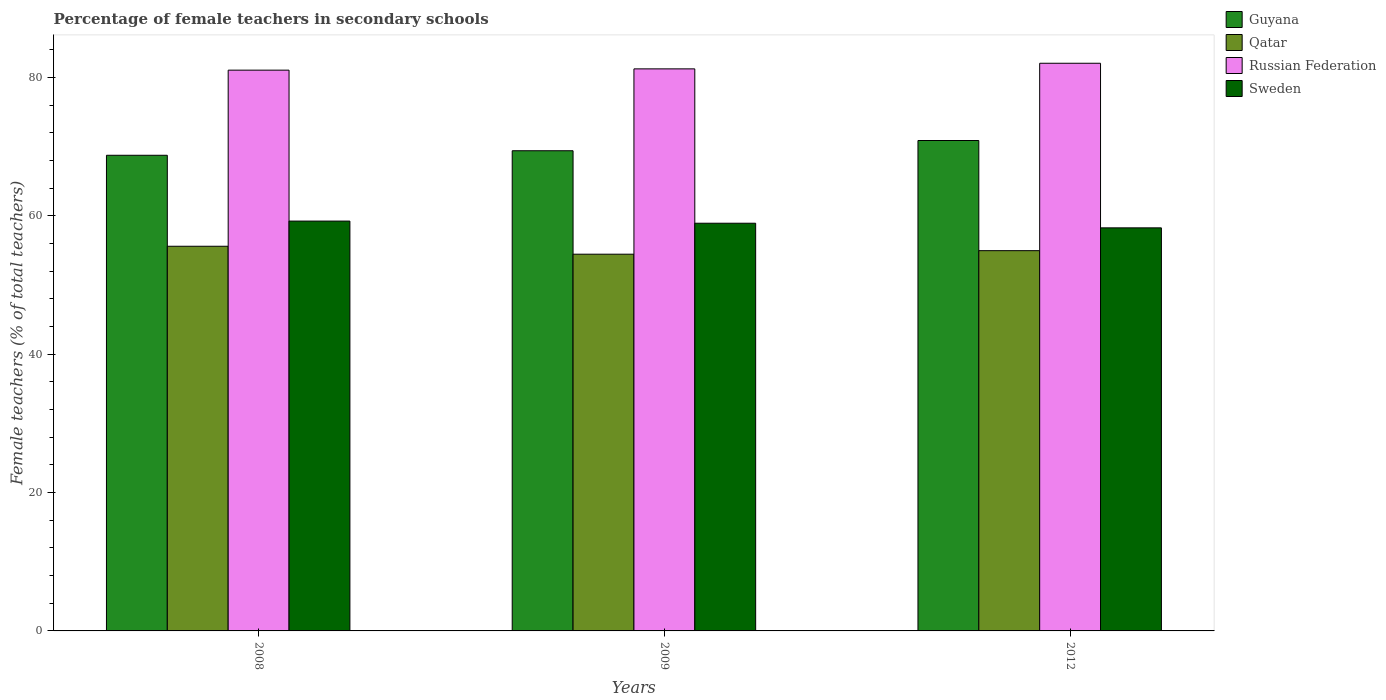How many different coloured bars are there?
Your response must be concise. 4. How many groups of bars are there?
Provide a succinct answer. 3. Are the number of bars on each tick of the X-axis equal?
Keep it short and to the point. Yes. How many bars are there on the 2nd tick from the right?
Keep it short and to the point. 4. What is the label of the 1st group of bars from the left?
Offer a very short reply. 2008. What is the percentage of female teachers in Russian Federation in 2008?
Your answer should be compact. 81.08. Across all years, what is the maximum percentage of female teachers in Qatar?
Provide a succinct answer. 55.62. Across all years, what is the minimum percentage of female teachers in Guyana?
Provide a succinct answer. 68.77. In which year was the percentage of female teachers in Sweden maximum?
Keep it short and to the point. 2008. What is the total percentage of female teachers in Guyana in the graph?
Your response must be concise. 209.11. What is the difference between the percentage of female teachers in Russian Federation in 2009 and that in 2012?
Your answer should be very brief. -0.81. What is the difference between the percentage of female teachers in Russian Federation in 2009 and the percentage of female teachers in Guyana in 2012?
Offer a terse response. 10.36. What is the average percentage of female teachers in Russian Federation per year?
Offer a very short reply. 81.48. In the year 2009, what is the difference between the percentage of female teachers in Sweden and percentage of female teachers in Guyana?
Your answer should be very brief. -10.48. What is the ratio of the percentage of female teachers in Sweden in 2008 to that in 2012?
Give a very brief answer. 1.02. Is the percentage of female teachers in Russian Federation in 2008 less than that in 2012?
Your response must be concise. Yes. What is the difference between the highest and the second highest percentage of female teachers in Russian Federation?
Your answer should be compact. 0.81. What is the difference between the highest and the lowest percentage of female teachers in Russian Federation?
Offer a very short reply. 1. What does the 4th bar from the left in 2008 represents?
Your response must be concise. Sweden. What does the 2nd bar from the right in 2012 represents?
Provide a short and direct response. Russian Federation. Is it the case that in every year, the sum of the percentage of female teachers in Guyana and percentage of female teachers in Sweden is greater than the percentage of female teachers in Russian Federation?
Provide a succinct answer. Yes. How many bars are there?
Your response must be concise. 12. How many years are there in the graph?
Your answer should be very brief. 3. What is the difference between two consecutive major ticks on the Y-axis?
Your response must be concise. 20. Are the values on the major ticks of Y-axis written in scientific E-notation?
Offer a very short reply. No. Where does the legend appear in the graph?
Ensure brevity in your answer.  Top right. How many legend labels are there?
Give a very brief answer. 4. How are the legend labels stacked?
Your answer should be very brief. Vertical. What is the title of the graph?
Ensure brevity in your answer.  Percentage of female teachers in secondary schools. What is the label or title of the X-axis?
Keep it short and to the point. Years. What is the label or title of the Y-axis?
Make the answer very short. Female teachers (% of total teachers). What is the Female teachers (% of total teachers) of Guyana in 2008?
Offer a terse response. 68.77. What is the Female teachers (% of total teachers) of Qatar in 2008?
Ensure brevity in your answer.  55.62. What is the Female teachers (% of total teachers) in Russian Federation in 2008?
Give a very brief answer. 81.08. What is the Female teachers (% of total teachers) of Sweden in 2008?
Your answer should be compact. 59.26. What is the Female teachers (% of total teachers) in Guyana in 2009?
Give a very brief answer. 69.43. What is the Female teachers (% of total teachers) in Qatar in 2009?
Your answer should be very brief. 54.47. What is the Female teachers (% of total teachers) in Russian Federation in 2009?
Offer a very short reply. 81.27. What is the Female teachers (% of total teachers) of Sweden in 2009?
Offer a very short reply. 58.95. What is the Female teachers (% of total teachers) of Guyana in 2012?
Offer a very short reply. 70.91. What is the Female teachers (% of total teachers) in Qatar in 2012?
Your response must be concise. 54.98. What is the Female teachers (% of total teachers) in Russian Federation in 2012?
Offer a very short reply. 82.08. What is the Female teachers (% of total teachers) in Sweden in 2012?
Your answer should be compact. 58.28. Across all years, what is the maximum Female teachers (% of total teachers) in Guyana?
Give a very brief answer. 70.91. Across all years, what is the maximum Female teachers (% of total teachers) in Qatar?
Your answer should be very brief. 55.62. Across all years, what is the maximum Female teachers (% of total teachers) of Russian Federation?
Your response must be concise. 82.08. Across all years, what is the maximum Female teachers (% of total teachers) of Sweden?
Provide a succinct answer. 59.26. Across all years, what is the minimum Female teachers (% of total teachers) of Guyana?
Provide a succinct answer. 68.77. Across all years, what is the minimum Female teachers (% of total teachers) in Qatar?
Provide a succinct answer. 54.47. Across all years, what is the minimum Female teachers (% of total teachers) in Russian Federation?
Offer a terse response. 81.08. Across all years, what is the minimum Female teachers (% of total teachers) in Sweden?
Your answer should be very brief. 58.28. What is the total Female teachers (% of total teachers) of Guyana in the graph?
Give a very brief answer. 209.11. What is the total Female teachers (% of total teachers) of Qatar in the graph?
Your answer should be compact. 165.07. What is the total Female teachers (% of total teachers) in Russian Federation in the graph?
Ensure brevity in your answer.  244.43. What is the total Female teachers (% of total teachers) in Sweden in the graph?
Make the answer very short. 176.49. What is the difference between the Female teachers (% of total teachers) of Guyana in 2008 and that in 2009?
Offer a very short reply. -0.66. What is the difference between the Female teachers (% of total teachers) in Qatar in 2008 and that in 2009?
Give a very brief answer. 1.15. What is the difference between the Female teachers (% of total teachers) of Russian Federation in 2008 and that in 2009?
Provide a short and direct response. -0.18. What is the difference between the Female teachers (% of total teachers) in Sweden in 2008 and that in 2009?
Make the answer very short. 0.31. What is the difference between the Female teachers (% of total teachers) in Guyana in 2008 and that in 2012?
Offer a terse response. -2.13. What is the difference between the Female teachers (% of total teachers) in Qatar in 2008 and that in 2012?
Your answer should be very brief. 0.64. What is the difference between the Female teachers (% of total teachers) of Russian Federation in 2008 and that in 2012?
Offer a very short reply. -1. What is the difference between the Female teachers (% of total teachers) in Sweden in 2008 and that in 2012?
Your response must be concise. 0.98. What is the difference between the Female teachers (% of total teachers) of Guyana in 2009 and that in 2012?
Your response must be concise. -1.48. What is the difference between the Female teachers (% of total teachers) in Qatar in 2009 and that in 2012?
Your answer should be very brief. -0.51. What is the difference between the Female teachers (% of total teachers) of Russian Federation in 2009 and that in 2012?
Give a very brief answer. -0.81. What is the difference between the Female teachers (% of total teachers) of Sweden in 2009 and that in 2012?
Your answer should be very brief. 0.67. What is the difference between the Female teachers (% of total teachers) of Guyana in 2008 and the Female teachers (% of total teachers) of Qatar in 2009?
Your answer should be compact. 14.3. What is the difference between the Female teachers (% of total teachers) of Guyana in 2008 and the Female teachers (% of total teachers) of Russian Federation in 2009?
Keep it short and to the point. -12.49. What is the difference between the Female teachers (% of total teachers) of Guyana in 2008 and the Female teachers (% of total teachers) of Sweden in 2009?
Ensure brevity in your answer.  9.82. What is the difference between the Female teachers (% of total teachers) in Qatar in 2008 and the Female teachers (% of total teachers) in Russian Federation in 2009?
Provide a short and direct response. -25.65. What is the difference between the Female teachers (% of total teachers) of Qatar in 2008 and the Female teachers (% of total teachers) of Sweden in 2009?
Give a very brief answer. -3.33. What is the difference between the Female teachers (% of total teachers) of Russian Federation in 2008 and the Female teachers (% of total teachers) of Sweden in 2009?
Ensure brevity in your answer.  22.13. What is the difference between the Female teachers (% of total teachers) in Guyana in 2008 and the Female teachers (% of total teachers) in Qatar in 2012?
Give a very brief answer. 13.79. What is the difference between the Female teachers (% of total teachers) in Guyana in 2008 and the Female teachers (% of total teachers) in Russian Federation in 2012?
Make the answer very short. -13.3. What is the difference between the Female teachers (% of total teachers) of Guyana in 2008 and the Female teachers (% of total teachers) of Sweden in 2012?
Provide a succinct answer. 10.5. What is the difference between the Female teachers (% of total teachers) in Qatar in 2008 and the Female teachers (% of total teachers) in Russian Federation in 2012?
Ensure brevity in your answer.  -26.46. What is the difference between the Female teachers (% of total teachers) in Qatar in 2008 and the Female teachers (% of total teachers) in Sweden in 2012?
Give a very brief answer. -2.66. What is the difference between the Female teachers (% of total teachers) in Russian Federation in 2008 and the Female teachers (% of total teachers) in Sweden in 2012?
Offer a terse response. 22.8. What is the difference between the Female teachers (% of total teachers) of Guyana in 2009 and the Female teachers (% of total teachers) of Qatar in 2012?
Offer a terse response. 14.45. What is the difference between the Female teachers (% of total teachers) in Guyana in 2009 and the Female teachers (% of total teachers) in Russian Federation in 2012?
Provide a succinct answer. -12.65. What is the difference between the Female teachers (% of total teachers) of Guyana in 2009 and the Female teachers (% of total teachers) of Sweden in 2012?
Offer a very short reply. 11.15. What is the difference between the Female teachers (% of total teachers) in Qatar in 2009 and the Female teachers (% of total teachers) in Russian Federation in 2012?
Your response must be concise. -27.61. What is the difference between the Female teachers (% of total teachers) in Qatar in 2009 and the Female teachers (% of total teachers) in Sweden in 2012?
Your response must be concise. -3.81. What is the difference between the Female teachers (% of total teachers) in Russian Federation in 2009 and the Female teachers (% of total teachers) in Sweden in 2012?
Make the answer very short. 22.99. What is the average Female teachers (% of total teachers) in Guyana per year?
Your answer should be very brief. 69.7. What is the average Female teachers (% of total teachers) in Qatar per year?
Provide a short and direct response. 55.02. What is the average Female teachers (% of total teachers) of Russian Federation per year?
Give a very brief answer. 81.48. What is the average Female teachers (% of total teachers) in Sweden per year?
Ensure brevity in your answer.  58.83. In the year 2008, what is the difference between the Female teachers (% of total teachers) of Guyana and Female teachers (% of total teachers) of Qatar?
Provide a succinct answer. 13.16. In the year 2008, what is the difference between the Female teachers (% of total teachers) in Guyana and Female teachers (% of total teachers) in Russian Federation?
Your answer should be very brief. -12.31. In the year 2008, what is the difference between the Female teachers (% of total teachers) in Guyana and Female teachers (% of total teachers) in Sweden?
Offer a very short reply. 9.52. In the year 2008, what is the difference between the Female teachers (% of total teachers) in Qatar and Female teachers (% of total teachers) in Russian Federation?
Your answer should be compact. -25.47. In the year 2008, what is the difference between the Female teachers (% of total teachers) of Qatar and Female teachers (% of total teachers) of Sweden?
Your answer should be very brief. -3.64. In the year 2008, what is the difference between the Female teachers (% of total teachers) of Russian Federation and Female teachers (% of total teachers) of Sweden?
Your response must be concise. 21.82. In the year 2009, what is the difference between the Female teachers (% of total teachers) of Guyana and Female teachers (% of total teachers) of Qatar?
Your response must be concise. 14.96. In the year 2009, what is the difference between the Female teachers (% of total teachers) in Guyana and Female teachers (% of total teachers) in Russian Federation?
Provide a short and direct response. -11.84. In the year 2009, what is the difference between the Female teachers (% of total teachers) in Guyana and Female teachers (% of total teachers) in Sweden?
Your answer should be very brief. 10.48. In the year 2009, what is the difference between the Female teachers (% of total teachers) in Qatar and Female teachers (% of total teachers) in Russian Federation?
Keep it short and to the point. -26.8. In the year 2009, what is the difference between the Female teachers (% of total teachers) in Qatar and Female teachers (% of total teachers) in Sweden?
Keep it short and to the point. -4.48. In the year 2009, what is the difference between the Female teachers (% of total teachers) in Russian Federation and Female teachers (% of total teachers) in Sweden?
Offer a terse response. 22.32. In the year 2012, what is the difference between the Female teachers (% of total teachers) of Guyana and Female teachers (% of total teachers) of Qatar?
Keep it short and to the point. 15.93. In the year 2012, what is the difference between the Female teachers (% of total teachers) of Guyana and Female teachers (% of total teachers) of Russian Federation?
Ensure brevity in your answer.  -11.17. In the year 2012, what is the difference between the Female teachers (% of total teachers) in Guyana and Female teachers (% of total teachers) in Sweden?
Offer a very short reply. 12.63. In the year 2012, what is the difference between the Female teachers (% of total teachers) of Qatar and Female teachers (% of total teachers) of Russian Federation?
Make the answer very short. -27.1. In the year 2012, what is the difference between the Female teachers (% of total teachers) of Qatar and Female teachers (% of total teachers) of Sweden?
Provide a short and direct response. -3.3. In the year 2012, what is the difference between the Female teachers (% of total teachers) in Russian Federation and Female teachers (% of total teachers) in Sweden?
Your answer should be very brief. 23.8. What is the ratio of the Female teachers (% of total teachers) of Guyana in 2008 to that in 2009?
Your response must be concise. 0.99. What is the ratio of the Female teachers (% of total teachers) of Qatar in 2008 to that in 2009?
Your answer should be compact. 1.02. What is the ratio of the Female teachers (% of total teachers) in Guyana in 2008 to that in 2012?
Give a very brief answer. 0.97. What is the ratio of the Female teachers (% of total teachers) of Qatar in 2008 to that in 2012?
Provide a short and direct response. 1.01. What is the ratio of the Female teachers (% of total teachers) of Russian Federation in 2008 to that in 2012?
Your answer should be very brief. 0.99. What is the ratio of the Female teachers (% of total teachers) in Sweden in 2008 to that in 2012?
Ensure brevity in your answer.  1.02. What is the ratio of the Female teachers (% of total teachers) in Guyana in 2009 to that in 2012?
Offer a terse response. 0.98. What is the ratio of the Female teachers (% of total teachers) in Russian Federation in 2009 to that in 2012?
Give a very brief answer. 0.99. What is the ratio of the Female teachers (% of total teachers) in Sweden in 2009 to that in 2012?
Provide a succinct answer. 1.01. What is the difference between the highest and the second highest Female teachers (% of total teachers) of Guyana?
Ensure brevity in your answer.  1.48. What is the difference between the highest and the second highest Female teachers (% of total teachers) in Qatar?
Make the answer very short. 0.64. What is the difference between the highest and the second highest Female teachers (% of total teachers) of Russian Federation?
Your response must be concise. 0.81. What is the difference between the highest and the second highest Female teachers (% of total teachers) of Sweden?
Offer a terse response. 0.31. What is the difference between the highest and the lowest Female teachers (% of total teachers) in Guyana?
Provide a short and direct response. 2.13. What is the difference between the highest and the lowest Female teachers (% of total teachers) of Qatar?
Your answer should be compact. 1.15. What is the difference between the highest and the lowest Female teachers (% of total teachers) of Sweden?
Offer a very short reply. 0.98. 